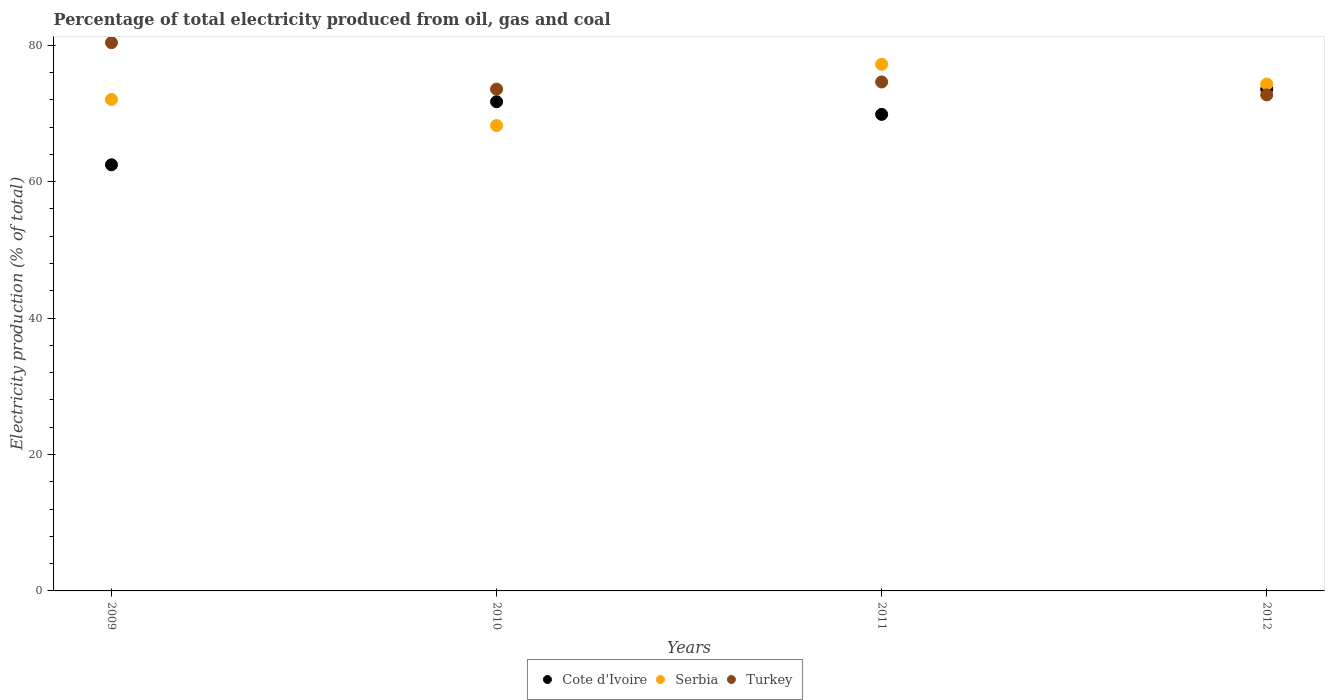Is the number of dotlines equal to the number of legend labels?
Provide a succinct answer. Yes. What is the electricity production in in Serbia in 2011?
Ensure brevity in your answer.  77.21. Across all years, what is the maximum electricity production in in Turkey?
Make the answer very short. 80.38. Across all years, what is the minimum electricity production in in Serbia?
Ensure brevity in your answer.  68.23. In which year was the electricity production in in Cote d'Ivoire minimum?
Keep it short and to the point. 2009. What is the total electricity production in in Turkey in the graph?
Provide a short and direct response. 301.27. What is the difference between the electricity production in in Turkey in 2009 and that in 2011?
Provide a short and direct response. 5.76. What is the difference between the electricity production in in Serbia in 2011 and the electricity production in in Turkey in 2012?
Give a very brief answer. 4.49. What is the average electricity production in in Cote d'Ivoire per year?
Your answer should be compact. 69.4. In the year 2012, what is the difference between the electricity production in in Cote d'Ivoire and electricity production in in Serbia?
Your response must be concise. -0.75. In how many years, is the electricity production in in Cote d'Ivoire greater than 48 %?
Offer a terse response. 4. What is the ratio of the electricity production in in Cote d'Ivoire in 2010 to that in 2012?
Your answer should be compact. 0.97. Is the electricity production in in Serbia in 2009 less than that in 2012?
Give a very brief answer. Yes. Is the difference between the electricity production in in Cote d'Ivoire in 2010 and 2011 greater than the difference between the electricity production in in Serbia in 2010 and 2011?
Your answer should be very brief. Yes. What is the difference between the highest and the second highest electricity production in in Cote d'Ivoire?
Offer a very short reply. 1.84. What is the difference between the highest and the lowest electricity production in in Cote d'Ivoire?
Offer a very short reply. 11.08. Is the sum of the electricity production in in Turkey in 2009 and 2012 greater than the maximum electricity production in in Serbia across all years?
Your answer should be compact. Yes. Does the electricity production in in Turkey monotonically increase over the years?
Give a very brief answer. No. Is the electricity production in in Turkey strictly greater than the electricity production in in Cote d'Ivoire over the years?
Ensure brevity in your answer.  No. How many dotlines are there?
Keep it short and to the point. 3. How many years are there in the graph?
Keep it short and to the point. 4. What is the difference between two consecutive major ticks on the Y-axis?
Give a very brief answer. 20. Are the values on the major ticks of Y-axis written in scientific E-notation?
Offer a terse response. No. Does the graph contain any zero values?
Your answer should be very brief. No. Does the graph contain grids?
Offer a very short reply. No. How many legend labels are there?
Ensure brevity in your answer.  3. How are the legend labels stacked?
Your answer should be very brief. Horizontal. What is the title of the graph?
Your answer should be very brief. Percentage of total electricity produced from oil, gas and coal. What is the label or title of the X-axis?
Make the answer very short. Years. What is the label or title of the Y-axis?
Give a very brief answer. Electricity production (% of total). What is the Electricity production (% of total) in Cote d'Ivoire in 2009?
Give a very brief answer. 62.48. What is the Electricity production (% of total) in Serbia in 2009?
Offer a terse response. 72.05. What is the Electricity production (% of total) of Turkey in 2009?
Your answer should be compact. 80.38. What is the Electricity production (% of total) in Cote d'Ivoire in 2010?
Your answer should be very brief. 71.72. What is the Electricity production (% of total) of Serbia in 2010?
Keep it short and to the point. 68.23. What is the Electricity production (% of total) of Turkey in 2010?
Offer a very short reply. 73.56. What is the Electricity production (% of total) in Cote d'Ivoire in 2011?
Your answer should be very brief. 69.86. What is the Electricity production (% of total) of Serbia in 2011?
Provide a short and direct response. 77.21. What is the Electricity production (% of total) of Turkey in 2011?
Provide a succinct answer. 74.62. What is the Electricity production (% of total) of Cote d'Ivoire in 2012?
Give a very brief answer. 73.56. What is the Electricity production (% of total) of Serbia in 2012?
Your answer should be compact. 74.31. What is the Electricity production (% of total) in Turkey in 2012?
Give a very brief answer. 72.72. Across all years, what is the maximum Electricity production (% of total) of Cote d'Ivoire?
Give a very brief answer. 73.56. Across all years, what is the maximum Electricity production (% of total) in Serbia?
Offer a terse response. 77.21. Across all years, what is the maximum Electricity production (% of total) in Turkey?
Provide a short and direct response. 80.38. Across all years, what is the minimum Electricity production (% of total) in Cote d'Ivoire?
Keep it short and to the point. 62.48. Across all years, what is the minimum Electricity production (% of total) of Serbia?
Ensure brevity in your answer.  68.23. Across all years, what is the minimum Electricity production (% of total) in Turkey?
Give a very brief answer. 72.72. What is the total Electricity production (% of total) of Cote d'Ivoire in the graph?
Your answer should be compact. 277.62. What is the total Electricity production (% of total) of Serbia in the graph?
Your response must be concise. 291.79. What is the total Electricity production (% of total) of Turkey in the graph?
Provide a short and direct response. 301.27. What is the difference between the Electricity production (% of total) of Cote d'Ivoire in 2009 and that in 2010?
Your response must be concise. -9.24. What is the difference between the Electricity production (% of total) in Serbia in 2009 and that in 2010?
Offer a terse response. 3.83. What is the difference between the Electricity production (% of total) in Turkey in 2009 and that in 2010?
Make the answer very short. 6.81. What is the difference between the Electricity production (% of total) of Cote d'Ivoire in 2009 and that in 2011?
Give a very brief answer. -7.39. What is the difference between the Electricity production (% of total) of Serbia in 2009 and that in 2011?
Provide a short and direct response. -5.15. What is the difference between the Electricity production (% of total) of Turkey in 2009 and that in 2011?
Ensure brevity in your answer.  5.76. What is the difference between the Electricity production (% of total) of Cote d'Ivoire in 2009 and that in 2012?
Offer a terse response. -11.08. What is the difference between the Electricity production (% of total) in Serbia in 2009 and that in 2012?
Give a very brief answer. -2.25. What is the difference between the Electricity production (% of total) of Turkey in 2009 and that in 2012?
Your response must be concise. 7.66. What is the difference between the Electricity production (% of total) of Cote d'Ivoire in 2010 and that in 2011?
Make the answer very short. 1.85. What is the difference between the Electricity production (% of total) in Serbia in 2010 and that in 2011?
Provide a succinct answer. -8.98. What is the difference between the Electricity production (% of total) in Turkey in 2010 and that in 2011?
Your answer should be compact. -1.06. What is the difference between the Electricity production (% of total) of Cote d'Ivoire in 2010 and that in 2012?
Your response must be concise. -1.84. What is the difference between the Electricity production (% of total) in Serbia in 2010 and that in 2012?
Ensure brevity in your answer.  -6.08. What is the difference between the Electricity production (% of total) of Turkey in 2010 and that in 2012?
Make the answer very short. 0.85. What is the difference between the Electricity production (% of total) in Cote d'Ivoire in 2011 and that in 2012?
Your answer should be compact. -3.7. What is the difference between the Electricity production (% of total) in Serbia in 2011 and that in 2012?
Your answer should be very brief. 2.9. What is the difference between the Electricity production (% of total) of Turkey in 2011 and that in 2012?
Give a very brief answer. 1.9. What is the difference between the Electricity production (% of total) in Cote d'Ivoire in 2009 and the Electricity production (% of total) in Serbia in 2010?
Offer a very short reply. -5.75. What is the difference between the Electricity production (% of total) in Cote d'Ivoire in 2009 and the Electricity production (% of total) in Turkey in 2010?
Make the answer very short. -11.09. What is the difference between the Electricity production (% of total) of Serbia in 2009 and the Electricity production (% of total) of Turkey in 2010?
Provide a succinct answer. -1.51. What is the difference between the Electricity production (% of total) in Cote d'Ivoire in 2009 and the Electricity production (% of total) in Serbia in 2011?
Ensure brevity in your answer.  -14.73. What is the difference between the Electricity production (% of total) in Cote d'Ivoire in 2009 and the Electricity production (% of total) in Turkey in 2011?
Give a very brief answer. -12.14. What is the difference between the Electricity production (% of total) in Serbia in 2009 and the Electricity production (% of total) in Turkey in 2011?
Offer a very short reply. -2.56. What is the difference between the Electricity production (% of total) in Cote d'Ivoire in 2009 and the Electricity production (% of total) in Serbia in 2012?
Your answer should be compact. -11.83. What is the difference between the Electricity production (% of total) of Cote d'Ivoire in 2009 and the Electricity production (% of total) of Turkey in 2012?
Provide a succinct answer. -10.24. What is the difference between the Electricity production (% of total) in Serbia in 2009 and the Electricity production (% of total) in Turkey in 2012?
Your response must be concise. -0.66. What is the difference between the Electricity production (% of total) of Cote d'Ivoire in 2010 and the Electricity production (% of total) of Serbia in 2011?
Offer a very short reply. -5.49. What is the difference between the Electricity production (% of total) in Cote d'Ivoire in 2010 and the Electricity production (% of total) in Turkey in 2011?
Give a very brief answer. -2.9. What is the difference between the Electricity production (% of total) in Serbia in 2010 and the Electricity production (% of total) in Turkey in 2011?
Your response must be concise. -6.39. What is the difference between the Electricity production (% of total) of Cote d'Ivoire in 2010 and the Electricity production (% of total) of Serbia in 2012?
Your answer should be very brief. -2.59. What is the difference between the Electricity production (% of total) in Cote d'Ivoire in 2010 and the Electricity production (% of total) in Turkey in 2012?
Ensure brevity in your answer.  -1. What is the difference between the Electricity production (% of total) of Serbia in 2010 and the Electricity production (% of total) of Turkey in 2012?
Give a very brief answer. -4.49. What is the difference between the Electricity production (% of total) in Cote d'Ivoire in 2011 and the Electricity production (% of total) in Serbia in 2012?
Provide a short and direct response. -4.44. What is the difference between the Electricity production (% of total) in Cote d'Ivoire in 2011 and the Electricity production (% of total) in Turkey in 2012?
Ensure brevity in your answer.  -2.85. What is the difference between the Electricity production (% of total) in Serbia in 2011 and the Electricity production (% of total) in Turkey in 2012?
Your answer should be very brief. 4.49. What is the average Electricity production (% of total) of Cote d'Ivoire per year?
Provide a short and direct response. 69.4. What is the average Electricity production (% of total) in Serbia per year?
Give a very brief answer. 72.95. What is the average Electricity production (% of total) in Turkey per year?
Your answer should be compact. 75.32. In the year 2009, what is the difference between the Electricity production (% of total) of Cote d'Ivoire and Electricity production (% of total) of Serbia?
Your answer should be compact. -9.58. In the year 2009, what is the difference between the Electricity production (% of total) of Cote d'Ivoire and Electricity production (% of total) of Turkey?
Provide a short and direct response. -17.9. In the year 2009, what is the difference between the Electricity production (% of total) in Serbia and Electricity production (% of total) in Turkey?
Ensure brevity in your answer.  -8.32. In the year 2010, what is the difference between the Electricity production (% of total) in Cote d'Ivoire and Electricity production (% of total) in Serbia?
Offer a very short reply. 3.49. In the year 2010, what is the difference between the Electricity production (% of total) of Cote d'Ivoire and Electricity production (% of total) of Turkey?
Provide a succinct answer. -1.84. In the year 2010, what is the difference between the Electricity production (% of total) in Serbia and Electricity production (% of total) in Turkey?
Your response must be concise. -5.34. In the year 2011, what is the difference between the Electricity production (% of total) of Cote d'Ivoire and Electricity production (% of total) of Serbia?
Your answer should be very brief. -7.34. In the year 2011, what is the difference between the Electricity production (% of total) in Cote d'Ivoire and Electricity production (% of total) in Turkey?
Make the answer very short. -4.75. In the year 2011, what is the difference between the Electricity production (% of total) of Serbia and Electricity production (% of total) of Turkey?
Give a very brief answer. 2.59. In the year 2012, what is the difference between the Electricity production (% of total) of Cote d'Ivoire and Electricity production (% of total) of Serbia?
Offer a terse response. -0.75. In the year 2012, what is the difference between the Electricity production (% of total) of Cote d'Ivoire and Electricity production (% of total) of Turkey?
Provide a succinct answer. 0.84. In the year 2012, what is the difference between the Electricity production (% of total) in Serbia and Electricity production (% of total) in Turkey?
Your response must be concise. 1.59. What is the ratio of the Electricity production (% of total) in Cote d'Ivoire in 2009 to that in 2010?
Keep it short and to the point. 0.87. What is the ratio of the Electricity production (% of total) in Serbia in 2009 to that in 2010?
Make the answer very short. 1.06. What is the ratio of the Electricity production (% of total) of Turkey in 2009 to that in 2010?
Your answer should be compact. 1.09. What is the ratio of the Electricity production (% of total) of Cote d'Ivoire in 2009 to that in 2011?
Your answer should be compact. 0.89. What is the ratio of the Electricity production (% of total) in Turkey in 2009 to that in 2011?
Ensure brevity in your answer.  1.08. What is the ratio of the Electricity production (% of total) in Cote d'Ivoire in 2009 to that in 2012?
Offer a very short reply. 0.85. What is the ratio of the Electricity production (% of total) of Serbia in 2009 to that in 2012?
Your answer should be compact. 0.97. What is the ratio of the Electricity production (% of total) in Turkey in 2009 to that in 2012?
Make the answer very short. 1.11. What is the ratio of the Electricity production (% of total) in Cote d'Ivoire in 2010 to that in 2011?
Your answer should be compact. 1.03. What is the ratio of the Electricity production (% of total) in Serbia in 2010 to that in 2011?
Ensure brevity in your answer.  0.88. What is the ratio of the Electricity production (% of total) of Turkey in 2010 to that in 2011?
Make the answer very short. 0.99. What is the ratio of the Electricity production (% of total) of Cote d'Ivoire in 2010 to that in 2012?
Your answer should be very brief. 0.97. What is the ratio of the Electricity production (% of total) in Serbia in 2010 to that in 2012?
Your answer should be compact. 0.92. What is the ratio of the Electricity production (% of total) of Turkey in 2010 to that in 2012?
Give a very brief answer. 1.01. What is the ratio of the Electricity production (% of total) in Cote d'Ivoire in 2011 to that in 2012?
Your answer should be compact. 0.95. What is the ratio of the Electricity production (% of total) of Serbia in 2011 to that in 2012?
Make the answer very short. 1.04. What is the ratio of the Electricity production (% of total) of Turkey in 2011 to that in 2012?
Provide a short and direct response. 1.03. What is the difference between the highest and the second highest Electricity production (% of total) in Cote d'Ivoire?
Ensure brevity in your answer.  1.84. What is the difference between the highest and the second highest Electricity production (% of total) in Serbia?
Your answer should be very brief. 2.9. What is the difference between the highest and the second highest Electricity production (% of total) of Turkey?
Provide a short and direct response. 5.76. What is the difference between the highest and the lowest Electricity production (% of total) in Cote d'Ivoire?
Offer a very short reply. 11.08. What is the difference between the highest and the lowest Electricity production (% of total) in Serbia?
Your answer should be compact. 8.98. What is the difference between the highest and the lowest Electricity production (% of total) of Turkey?
Your answer should be very brief. 7.66. 